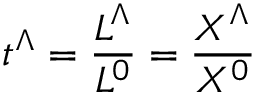<formula> <loc_0><loc_0><loc_500><loc_500>t ^ { \Lambda } = { \frac { L ^ { \Lambda } } { L ^ { 0 } } } = { \frac { X ^ { \Lambda } } { X ^ { 0 } } }</formula> 